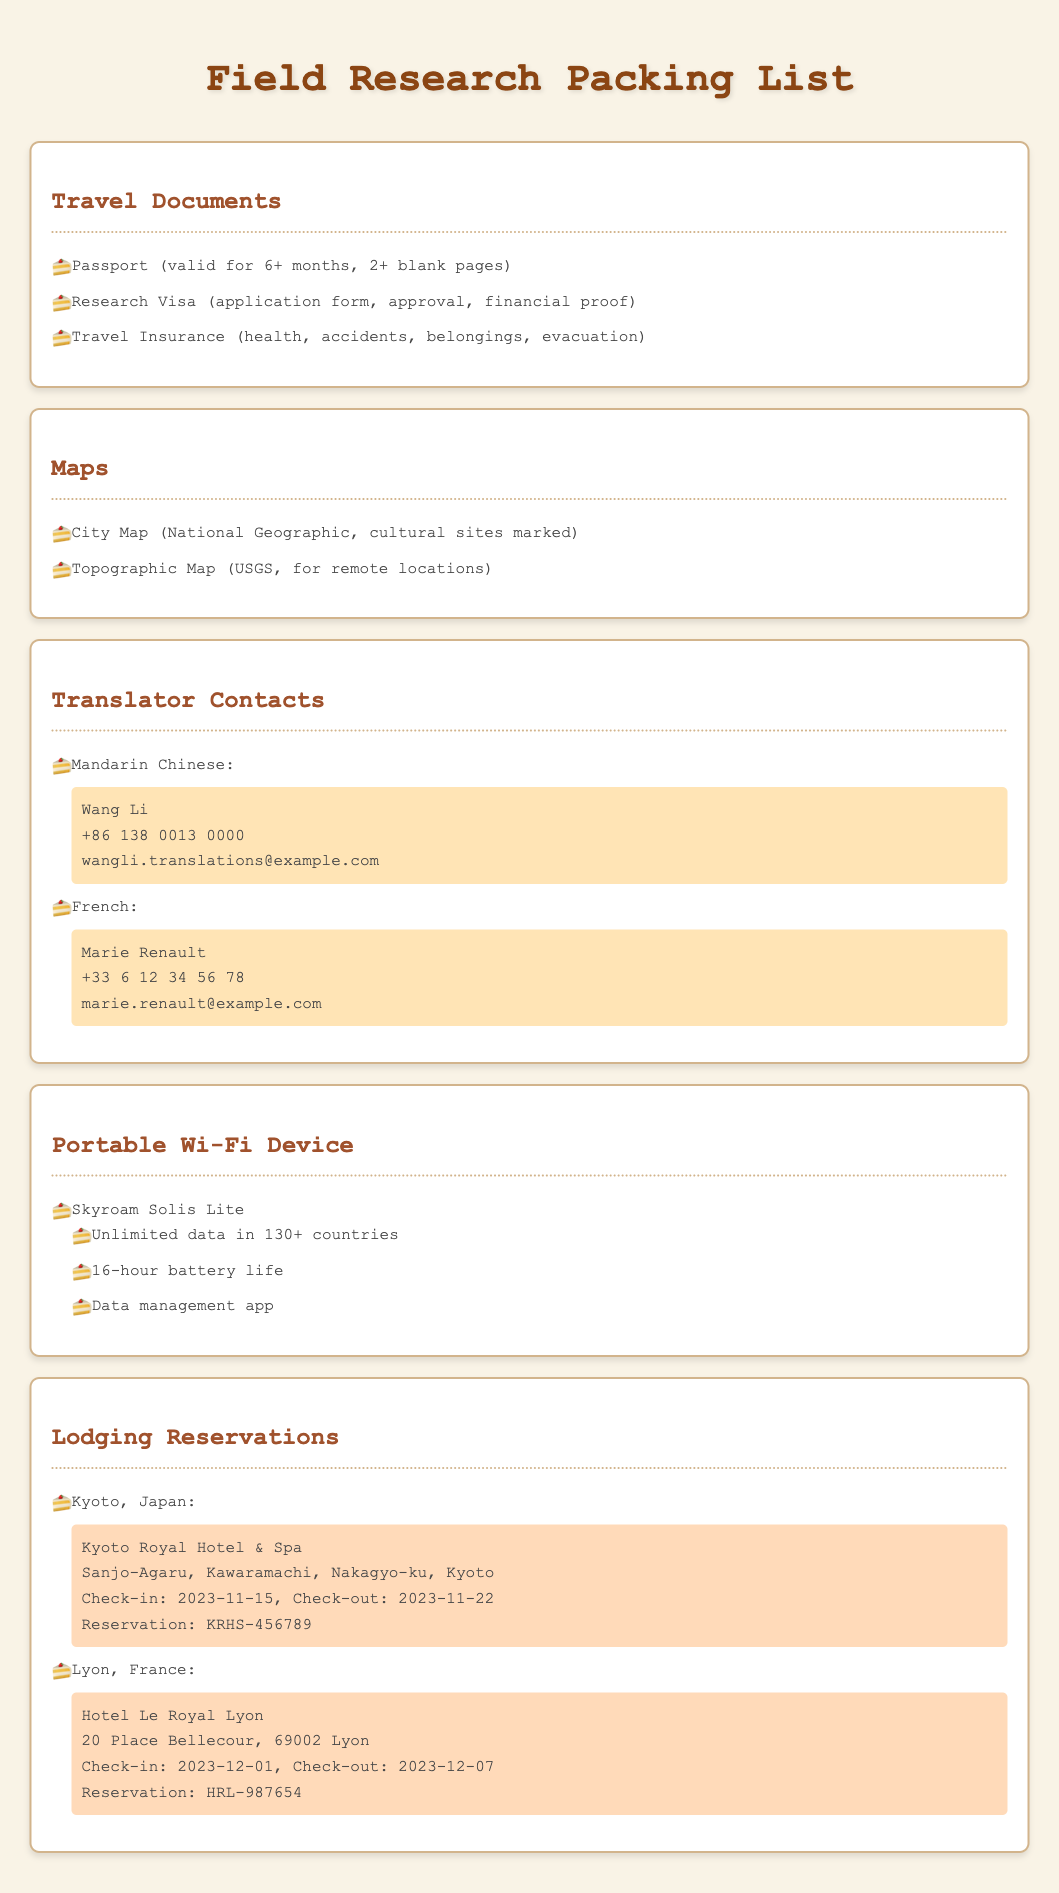What is required for travel insurance? The travel insurance section specifies that it should cover health, accidents, belongings, and evacuation.
Answer: health, accidents, belongings, evacuation How long must the passport be valid? The document states that the passport must be valid for 6 or more months.
Answer: 6+ months What is the name of the portable Wi-Fi device mentioned? The packing list specifies the portable Wi-Fi device as Skyroam Solis Lite.
Answer: Skyroam Solis Lite When is the check-out date for Kyoto lodging? The lodging reservation for Kyoto states the check-out date is 2023-11-22.
Answer: 2023-11-22 Who is the translator for Mandarin Chinese? The document lists Wang Li as the translator for Mandarin Chinese.
Answer: Wang Li What country is Lyon located in? The lodging section lists Lyon, France as the location.
Answer: France How many countries does the portable Wi-Fi device provide unlimited data? The portable Wi-Fi device specifies unlimited data is available in 130+ countries.
Answer: 130+ What is the reservation number for Hotel Le Royal Lyon? The reservation section provides the reservation number as HRL-987654.
Answer: HRL-987654 